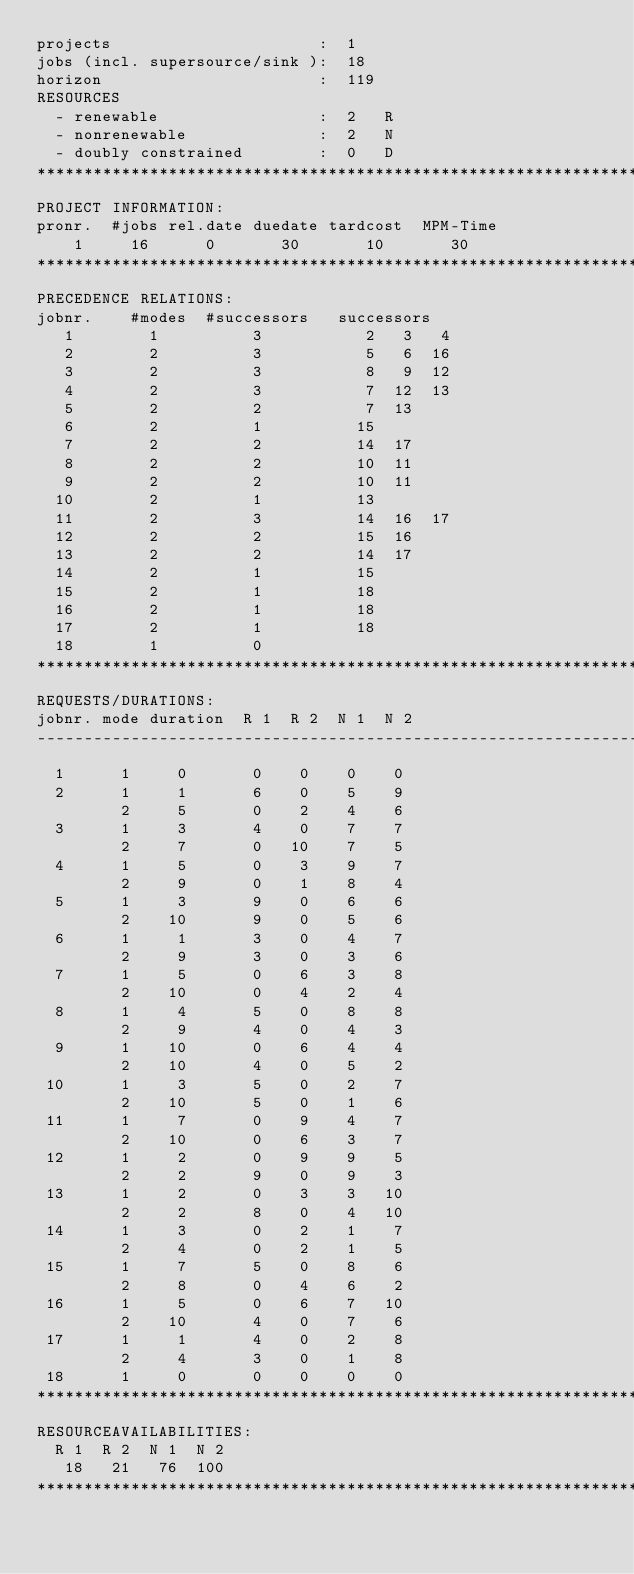<code> <loc_0><loc_0><loc_500><loc_500><_ObjectiveC_>projects                      :  1
jobs (incl. supersource/sink ):  18
horizon                       :  119
RESOURCES
  - renewable                 :  2   R
  - nonrenewable              :  2   N
  - doubly constrained        :  0   D
************************************************************************
PROJECT INFORMATION:
pronr.  #jobs rel.date duedate tardcost  MPM-Time
    1     16      0       30       10       30
************************************************************************
PRECEDENCE RELATIONS:
jobnr.    #modes  #successors   successors
   1        1          3           2   3   4
   2        2          3           5   6  16
   3        2          3           8   9  12
   4        2          3           7  12  13
   5        2          2           7  13
   6        2          1          15
   7        2          2          14  17
   8        2          2          10  11
   9        2          2          10  11
  10        2          1          13
  11        2          3          14  16  17
  12        2          2          15  16
  13        2          2          14  17
  14        2          1          15
  15        2          1          18
  16        2          1          18
  17        2          1          18
  18        1          0        
************************************************************************
REQUESTS/DURATIONS:
jobnr. mode duration  R 1  R 2  N 1  N 2
------------------------------------------------------------------------
  1      1     0       0    0    0    0
  2      1     1       6    0    5    9
         2     5       0    2    4    6
  3      1     3       4    0    7    7
         2     7       0   10    7    5
  4      1     5       0    3    9    7
         2     9       0    1    8    4
  5      1     3       9    0    6    6
         2    10       9    0    5    6
  6      1     1       3    0    4    7
         2     9       3    0    3    6
  7      1     5       0    6    3    8
         2    10       0    4    2    4
  8      1     4       5    0    8    8
         2     9       4    0    4    3
  9      1    10       0    6    4    4
         2    10       4    0    5    2
 10      1     3       5    0    2    7
         2    10       5    0    1    6
 11      1     7       0    9    4    7
         2    10       0    6    3    7
 12      1     2       0    9    9    5
         2     2       9    0    9    3
 13      1     2       0    3    3   10
         2     2       8    0    4   10
 14      1     3       0    2    1    7
         2     4       0    2    1    5
 15      1     7       5    0    8    6
         2     8       0    4    6    2
 16      1     5       0    6    7   10
         2    10       4    0    7    6
 17      1     1       4    0    2    8
         2     4       3    0    1    8
 18      1     0       0    0    0    0
************************************************************************
RESOURCEAVAILABILITIES:
  R 1  R 2  N 1  N 2
   18   21   76  100
************************************************************************
</code> 